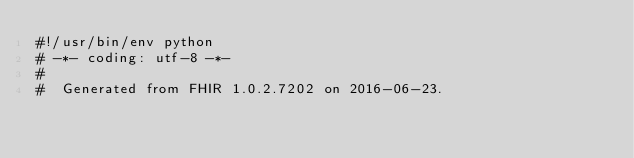<code> <loc_0><loc_0><loc_500><loc_500><_Python_>#!/usr/bin/env python
# -*- coding: utf-8 -*-
#
#  Generated from FHIR 1.0.2.7202 on 2016-06-23.</code> 